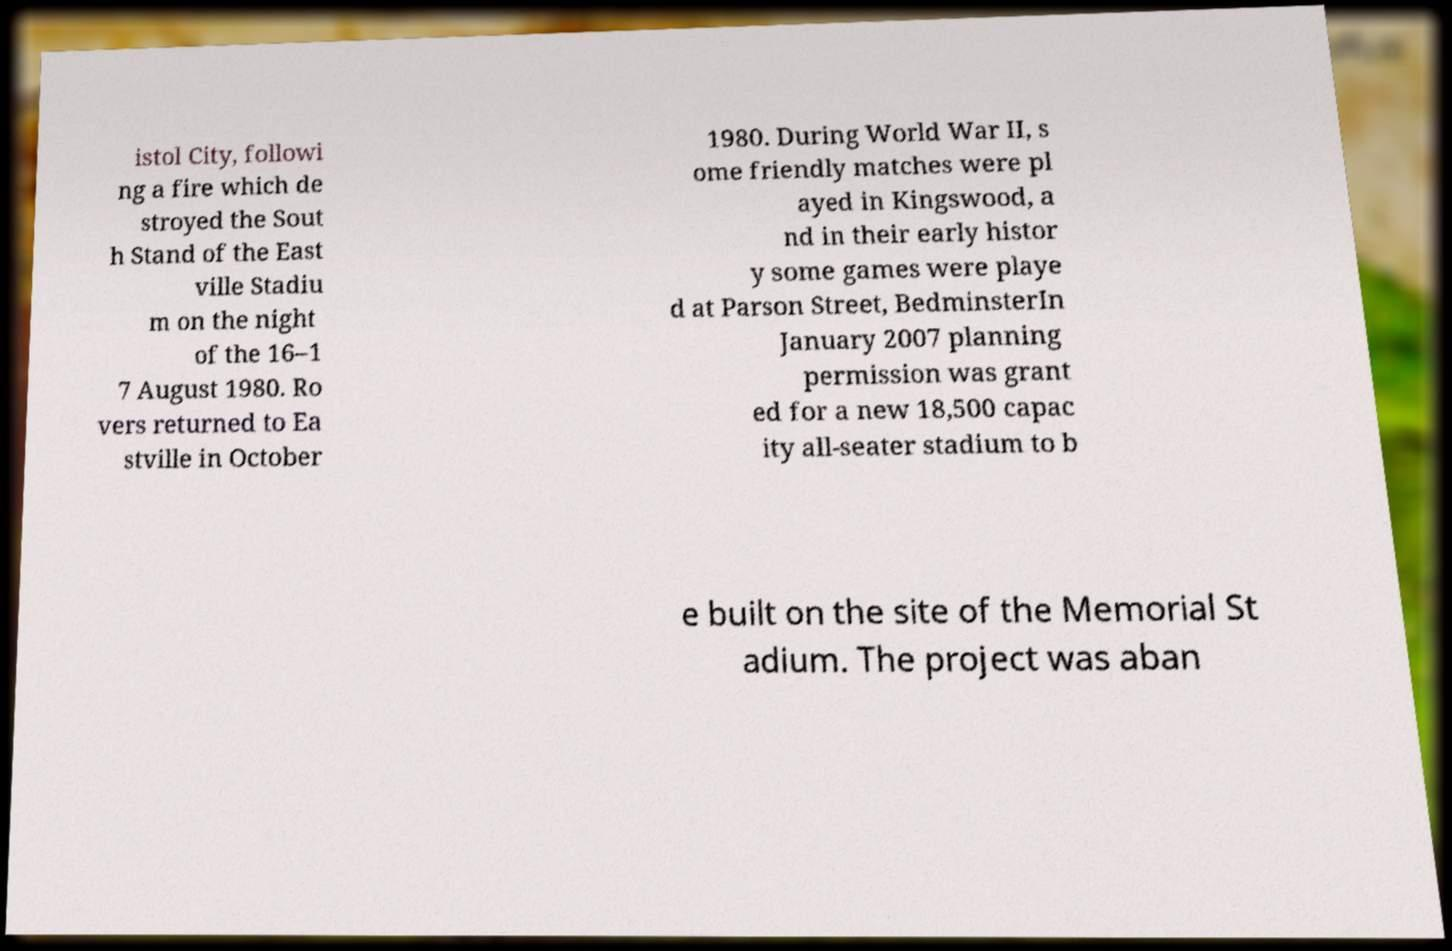I need the written content from this picture converted into text. Can you do that? istol City, followi ng a fire which de stroyed the Sout h Stand of the East ville Stadiu m on the night of the 16–1 7 August 1980. Ro vers returned to Ea stville in October 1980. During World War II, s ome friendly matches were pl ayed in Kingswood, a nd in their early histor y some games were playe d at Parson Street, BedminsterIn January 2007 planning permission was grant ed for a new 18,500 capac ity all-seater stadium to b e built on the site of the Memorial St adium. The project was aban 